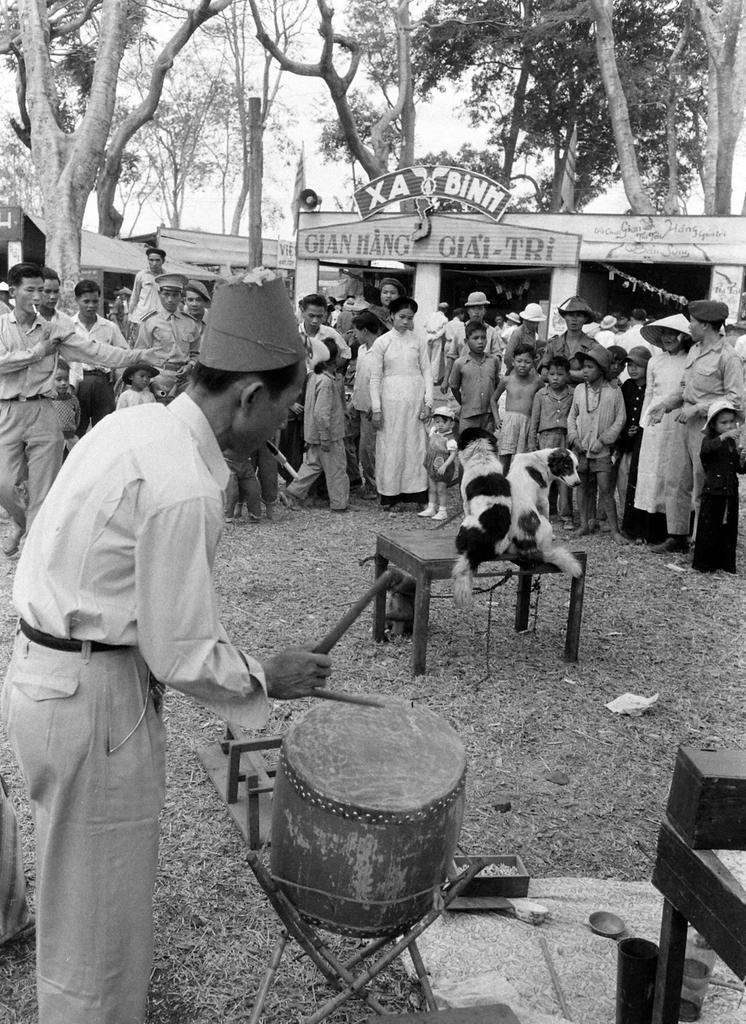What is the person in the image doing? The person is standing and playing a musical instrument. What is on the table in the image? There are dogs on a table. What can be seen in the background of the image? There are people, a board, and trees visible in the background. What type of pear is being used as a bat in the baseball game in the image? There is no pear or baseball game present in the image. 